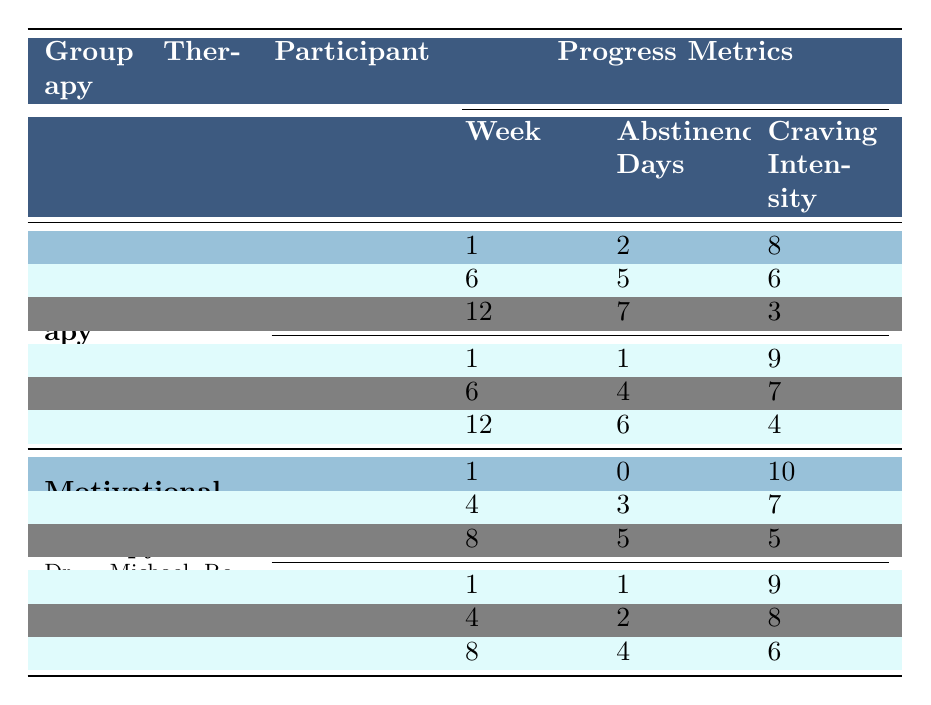What is the average craving intensity for John Smith across all weeks? For John Smith, the craving intensity scores are 8, 6, and 3. To find the average, add these scores: 8 + 6 + 3 = 17. Now, divide by the number of weeks, which is 3: 17 / 3 = 5.67.
Answer: 5.67 Which participant in the Cognitive Behavioral Therapy had the highest abstinence days in week 12? In week 12, John Smith had 7 abstinence days and Emily Chen had 6 abstinence days. Therefore, John Smith had the highest number of abstinence days in that week.
Answer: John Smith What is the cessation of use for Lisa Thompson from week 1 to week 8? Lisa Thompson had 0 abstinence days in week 1 and 5 abstinence days in week 8. The difference is 5 - 0 = 5 days of increase in abstinence.
Answer: 5 days Did David Williams improve his emotional regulation score throughout the therapy? David Williams' emotional regulation scores were 3, 4, and 6 in weeks 1, 4, and 8, respectively. Since these scores increased over time, we can conclude that he did improve.
Answer: Yes What is the overall average participant satisfaction for the therapeutic interventions listed? The average participant satisfaction scores are 8.5 for Mindfulness Training, 7.8 for Art Therapy, and 8.2 for Group Psychoeducation. To find the overall average, add these scores: 8.5 + 7.8 + 8.2 = 24.5, and divide by 3 (the number of interventions): 24.5 / 3 = 8.17.
Answer: 8.17 Who had the lowest craving intensity in week 8 within each session type? In the Motivational Enhancement Therapy, Lisa Thompson had a craving intensity score of 5 in week 8, and in the Cognitive Behavioral Therapy, John Smith had a score of 3 in week 12. Comparing both, John Smith had the lowest craving level.
Answer: John Smith What is the completion rate of the therapy program? The completion rate is explicitly stated in the overall program outcomes as 0.75, which translates to 75%.
Answer: 0.75 How much did Emily Chen's craving intensity reduce from week 1 to week 12? In week 1, Emily Chen's craving intensity was 9, and by week 12 it was reduced to 4. To find the reduction, subtract these values: 9 - 4 = 5.
Answer: 5 What are the reported benefits of Mindfulness Training? The reported benefits of Mindfulness Training include improved emotional awareness, reduced stress, and enhanced coping skills, as listed in the therapeutic interventions section.
Answer: Improved emotional awareness, reduced stress, enhanced coping skills Has any participant shown a decrease in both craving intensity and increase in abstinence days from the beginning to the end of their respective sessions? John Smith's craving intensity decreased from 8 to 3 while his abstinence days increased from 2 to 7. Similarly, Lisa Thompson's craving intensity decreased from 10 to 5, and her abstinence days increased from 0 to 5. Thus, both show progress in these metrics.
Answer: Yes 